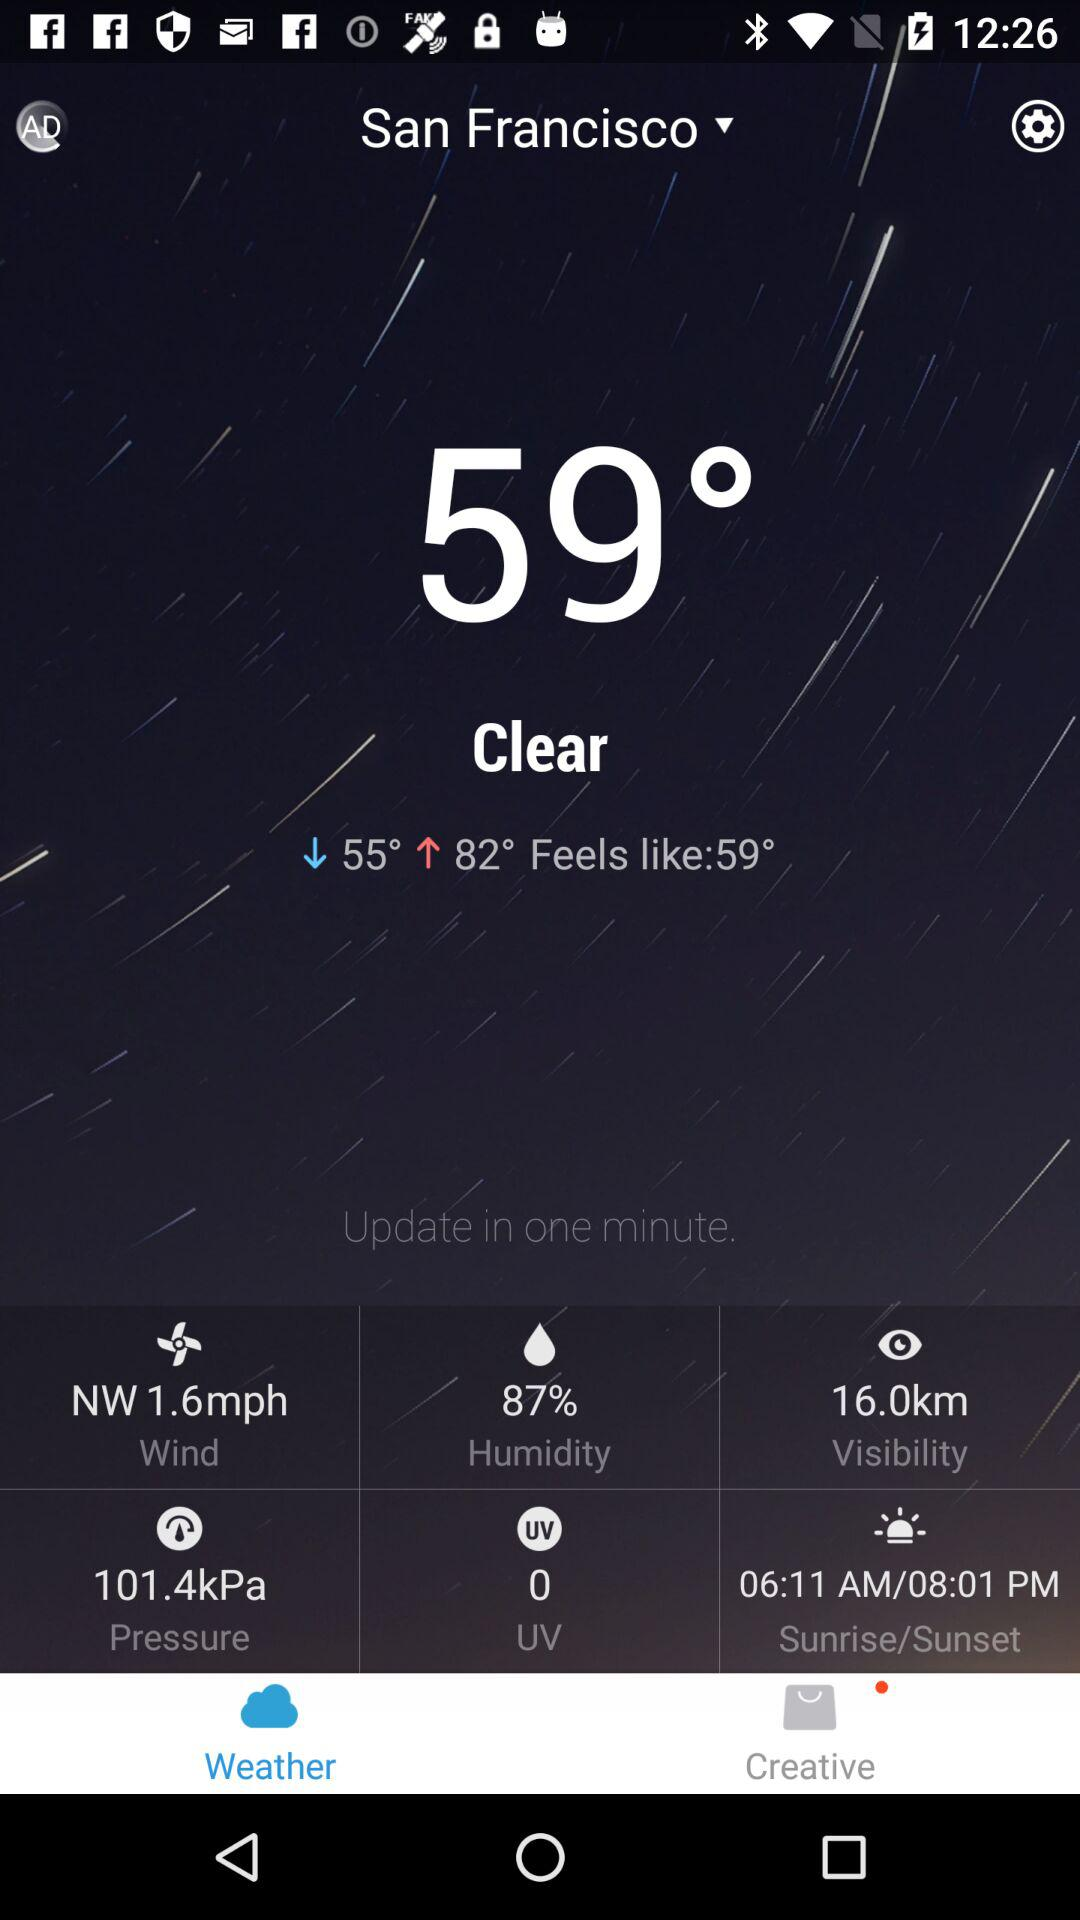What is the current wind speed?
Answer the question using a single word or phrase. 1.6 mph 